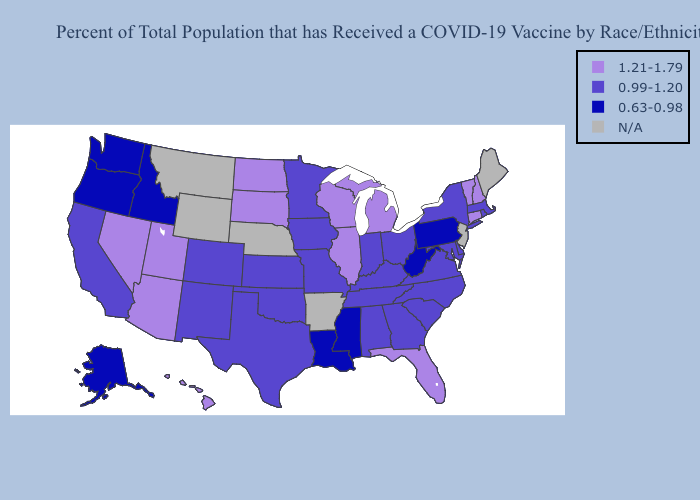What is the value of Minnesota?
Be succinct. 0.99-1.20. What is the lowest value in the Northeast?
Keep it brief. 0.63-0.98. Does Vermont have the highest value in the Northeast?
Be succinct. Yes. Among the states that border Pennsylvania , does New York have the lowest value?
Be succinct. No. Which states hav the highest value in the Northeast?
Quick response, please. Connecticut, New Hampshire, Vermont. Name the states that have a value in the range 1.21-1.79?
Answer briefly. Arizona, Connecticut, Florida, Hawaii, Illinois, Michigan, Nevada, New Hampshire, North Dakota, South Dakota, Utah, Vermont, Wisconsin. Among the states that border Kentucky , which have the lowest value?
Answer briefly. West Virginia. Does the first symbol in the legend represent the smallest category?
Short answer required. No. What is the lowest value in the USA?
Answer briefly. 0.63-0.98. Which states have the lowest value in the MidWest?
Give a very brief answer. Indiana, Iowa, Kansas, Minnesota, Missouri, Ohio. How many symbols are there in the legend?
Quick response, please. 4. Which states have the highest value in the USA?
Be succinct. Arizona, Connecticut, Florida, Hawaii, Illinois, Michigan, Nevada, New Hampshire, North Dakota, South Dakota, Utah, Vermont, Wisconsin. What is the value of Virginia?
Answer briefly. 0.99-1.20. What is the value of Montana?
Answer briefly. N/A. Name the states that have a value in the range 0.99-1.20?
Be succinct. Alabama, California, Colorado, Delaware, Georgia, Indiana, Iowa, Kansas, Kentucky, Maryland, Massachusetts, Minnesota, Missouri, New Mexico, New York, North Carolina, Ohio, Oklahoma, Rhode Island, South Carolina, Tennessee, Texas, Virginia. 